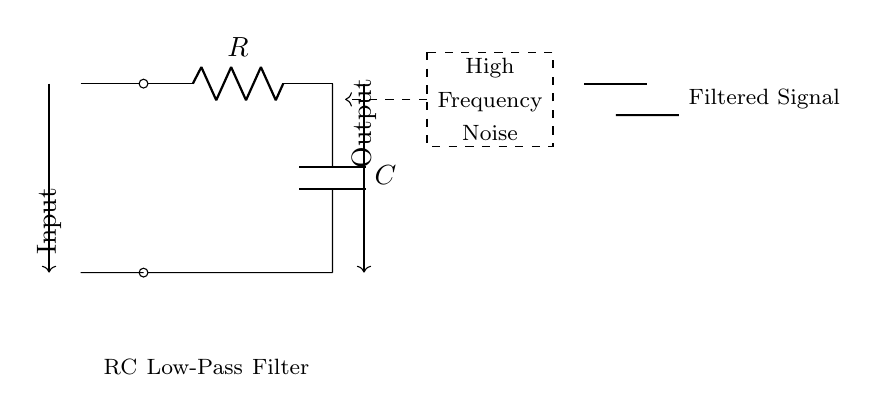What components are in this circuit? The circuit diagram shows a resistor (R) and a capacitor (C) connected in series, which are the main components of the RC low-pass filter.
Answer: Resistor and Capacitor What is the purpose of this circuit? This RC low-pass filter is designed to reduce high frequency noise in audio signals, allowing low-frequency signals to pass through while attenuating the higher frequencies.
Answer: Noise reduction What type of filter is represented by this circuit? The circuit represents a low-pass filter, which allows signals with a frequency lower than a certain cutoff frequency to pass through while attenuating frequencies higher than that cutoff.
Answer: Low-pass filter What happens to high frequency noise in this circuit? The high frequency noise is attenuated or reduced as it passes through the circuit, meaning the output signal will contain less of those higher frequencies.
Answer: Attenuated What is the role of the capacitor in this circuit? The capacitor stores and releases charge, affecting the timing and frequency characteristics of the circuit, contributing to the filtering effect by blocking high-frequency signals while allowing lower frequencies to pass.
Answer: To filter high frequencies What determines the cutoff frequency in this RC filter? The cutoff frequency is determined by the values of the resistor (R) and capacitor (C) in the circuit, specifically calculated using the formula 1 divided by 2πRC.
Answer: Resistor and Capacitor values How is the output signal affected by the input signal? The output signal becomes smoother with less high-frequency noise compared to the input signal, providing a cleaner audio output.
Answer: Smoother output 